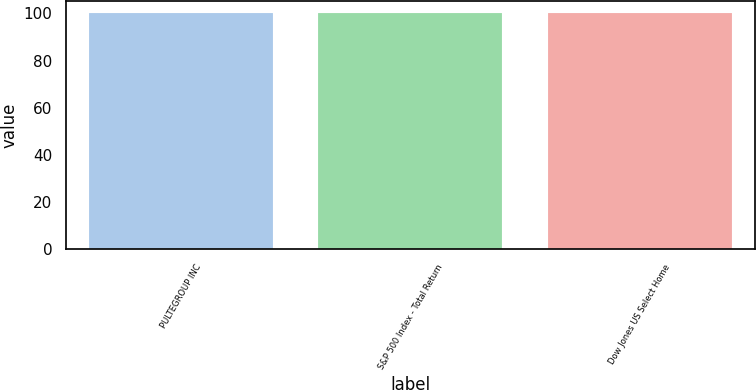<chart> <loc_0><loc_0><loc_500><loc_500><bar_chart><fcel>PULTEGROUP INC<fcel>S&P 500 Index - Total Return<fcel>Dow Jones US Select Home<nl><fcel>100<fcel>100.1<fcel>100.2<nl></chart> 